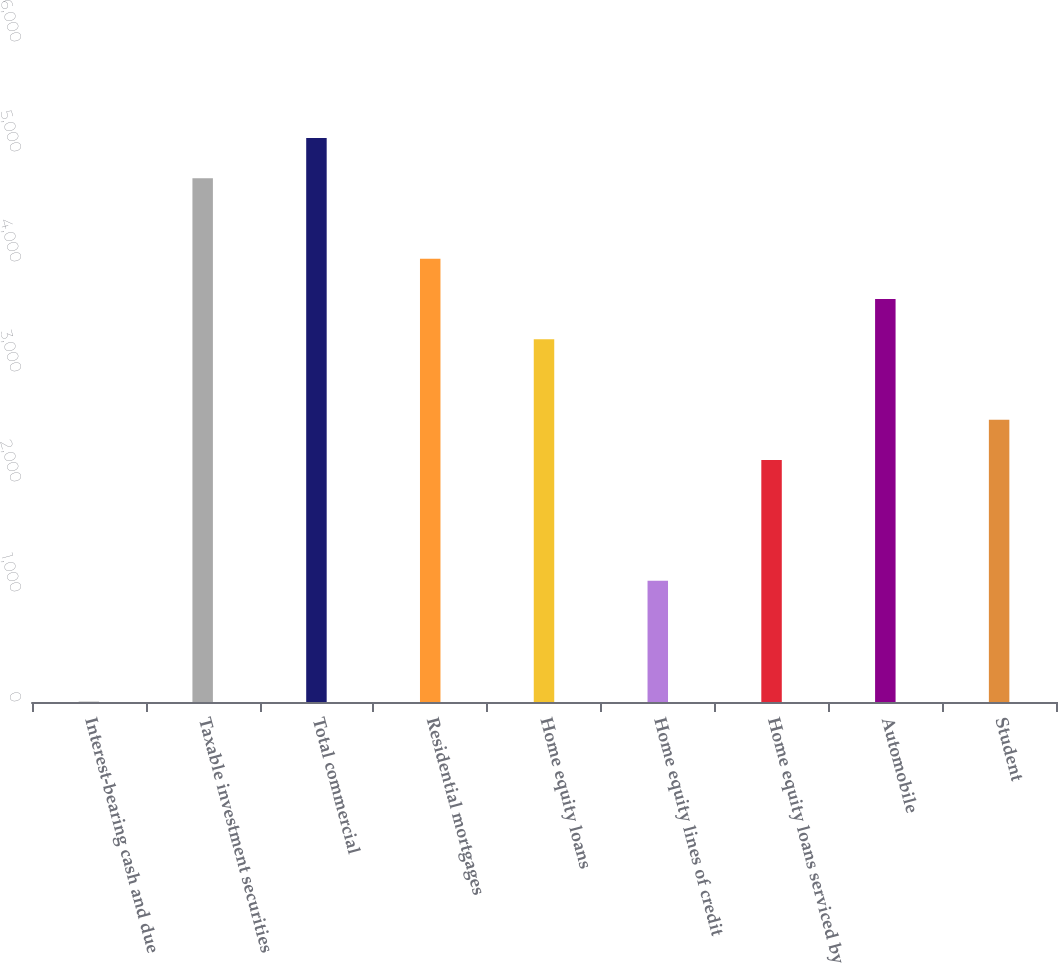Convert chart to OTSL. <chart><loc_0><loc_0><loc_500><loc_500><bar_chart><fcel>Interest-bearing cash and due<fcel>Taxable investment securities<fcel>Total commercial<fcel>Residential mortgages<fcel>Home equity loans<fcel>Home equity lines of credit<fcel>Home equity loans serviced by<fcel>Automobile<fcel>Student<nl><fcel>5<fcel>4761.7<fcel>5127.6<fcel>4029.9<fcel>3298.1<fcel>1102.7<fcel>2200.4<fcel>3664<fcel>2566.3<nl></chart> 